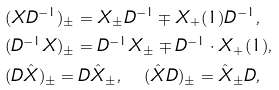<formula> <loc_0><loc_0><loc_500><loc_500>& ( X D ^ { - 1 } ) _ { \pm } = X _ { \pm } D ^ { - 1 } \mp X _ { + } ( 1 ) D ^ { - 1 } , \\ & ( D ^ { - 1 } X ) _ { \pm } = D ^ { - 1 } X _ { \pm } \mp D ^ { - 1 } \cdot X _ { + } ( 1 ) , \\ & ( D \hat { X } ) _ { \pm } = D \hat { X } _ { \pm } , \quad ( \hat { X } D ) _ { \pm } = \hat { X } _ { \pm } D ,</formula> 